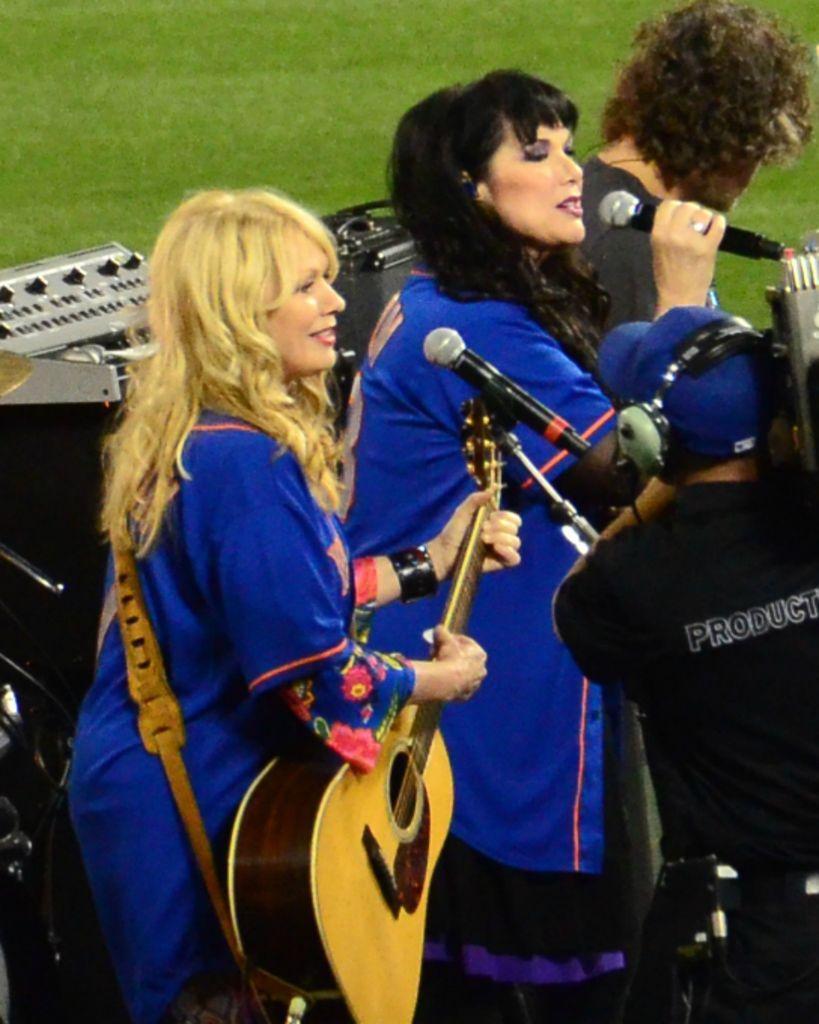In one or two sentences, can you explain what this image depicts? On the left a woman is playing guitar beside her there is a woman singing on mic. In the background there is a man,musical instruments,amplifier and grass. On the right a person is recording the performance and he is wearing headphones on his ears. 